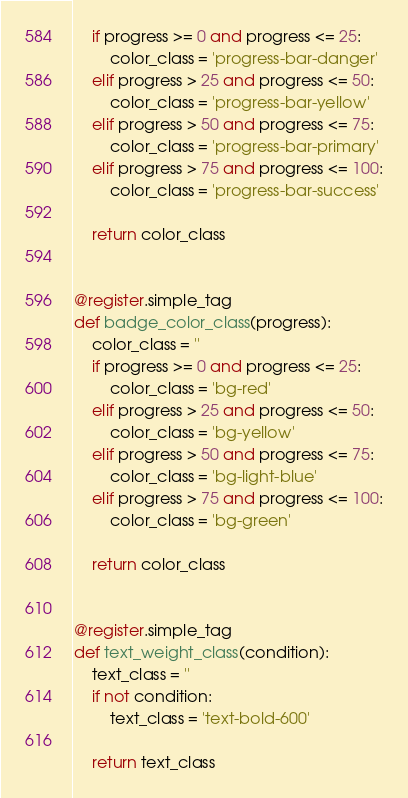Convert code to text. <code><loc_0><loc_0><loc_500><loc_500><_Python_>    if progress >= 0 and progress <= 25:
        color_class = 'progress-bar-danger'
    elif progress > 25 and progress <= 50:
        color_class = 'progress-bar-yellow'
    elif progress > 50 and progress <= 75:
        color_class = 'progress-bar-primary'
    elif progress > 75 and progress <= 100:
        color_class = 'progress-bar-success'

    return color_class


@register.simple_tag
def badge_color_class(progress):
    color_class = ''
    if progress >= 0 and progress <= 25:
        color_class = 'bg-red'
    elif progress > 25 and progress <= 50:
        color_class = 'bg-yellow'
    elif progress > 50 and progress <= 75:
        color_class = 'bg-light-blue'
    elif progress > 75 and progress <= 100:
        color_class = 'bg-green'

    return color_class


@register.simple_tag
def text_weight_class(condition):
    text_class = ''
    if not condition:
        text_class = 'text-bold-600'

    return text_class
</code> 